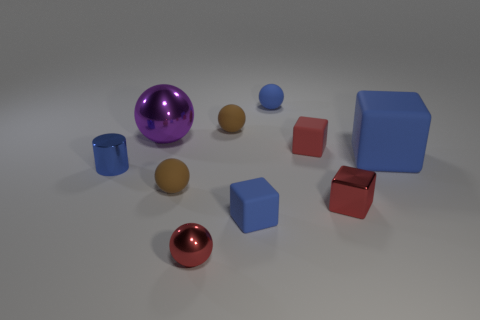Subtract 2 cubes. How many cubes are left? 2 Subtract all purple spheres. How many spheres are left? 4 Subtract all red rubber blocks. How many blocks are left? 3 Subtract all red spheres. Subtract all gray blocks. How many spheres are left? 4 Subtract all cylinders. How many objects are left? 9 Subtract 1 red spheres. How many objects are left? 9 Subtract all matte things. Subtract all red matte things. How many objects are left? 3 Add 3 big shiny balls. How many big shiny balls are left? 4 Add 4 blue matte things. How many blue matte things exist? 7 